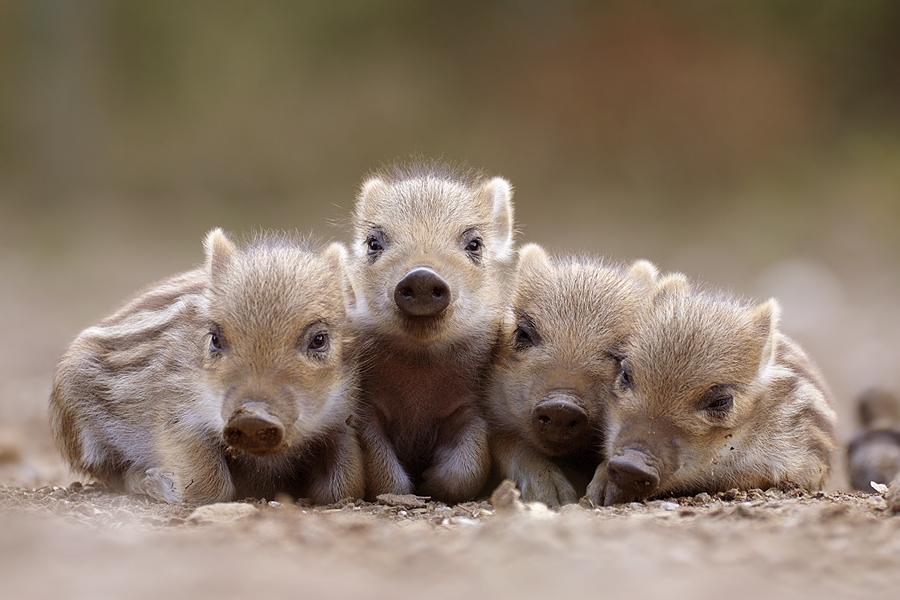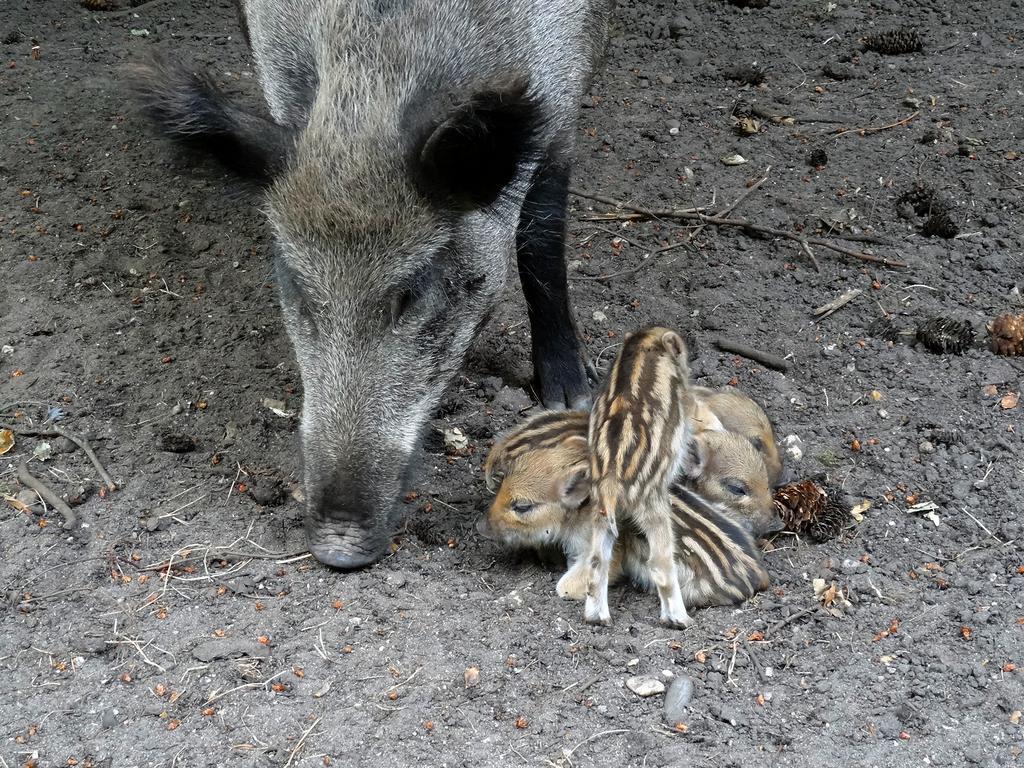The first image is the image on the left, the second image is the image on the right. Evaluate the accuracy of this statement regarding the images: "One of the animals in the image on the left is not striped.". Is it true? Answer yes or no. No. The first image is the image on the left, the second image is the image on the right. Analyze the images presented: Is the assertion "An image shows just one striped baby wild pig, which is turned leftward and standing on brown ground." valid? Answer yes or no. No. 